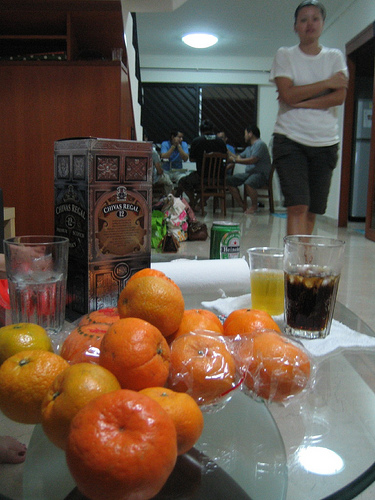How many people are visible? There are two people standing in the background. The focus of the photograph is more on the items in the foreground which include several oranges and two glasses, one appears to contain a dark liquid like soda. 